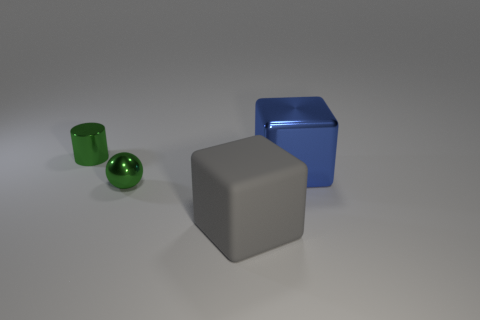The small thing behind the green sphere is what color?
Give a very brief answer. Green. Is the big gray rubber object the same shape as the big shiny object?
Your answer should be compact. Yes. What is the color of the object that is behind the small green metallic ball and to the left of the big gray object?
Keep it short and to the point. Green. There is a green metal thing that is behind the tiny shiny ball; does it have the same size as the green metallic thing in front of the blue object?
Keep it short and to the point. Yes. Is the size of the metallic cylinder the same as the gray cube?
Provide a short and direct response. No. What is the color of the cube that is to the right of the large cube that is in front of the large blue block?
Your answer should be very brief. Blue. Is the number of shiny spheres that are to the right of the gray thing less than the number of large gray blocks in front of the cylinder?
Ensure brevity in your answer.  Yes. Does the green ball have the same size as the green thing that is behind the blue shiny object?
Offer a terse response. Yes. What is the shape of the thing that is both to the left of the big blue block and on the right side of the shiny sphere?
Provide a short and direct response. Cube. There is a blue object that is the same material as the small green ball; what size is it?
Provide a succinct answer. Large. 